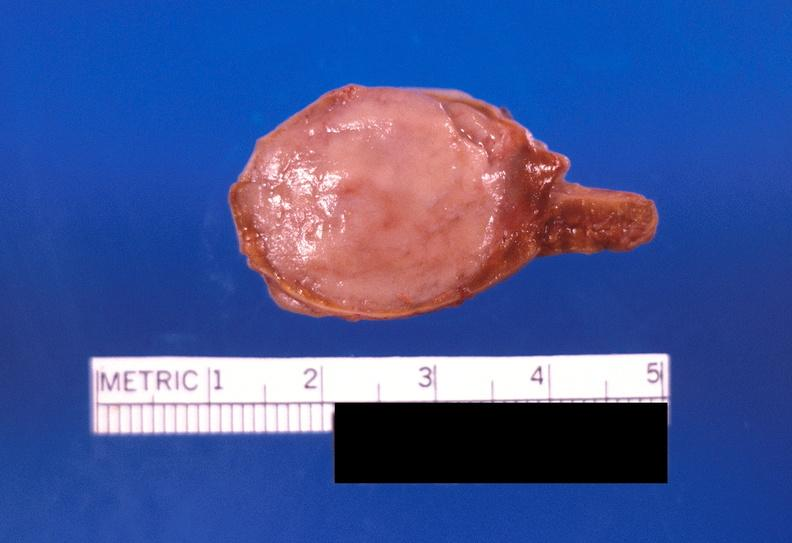s endocrine present?
Answer the question using a single word or phrase. Yes 